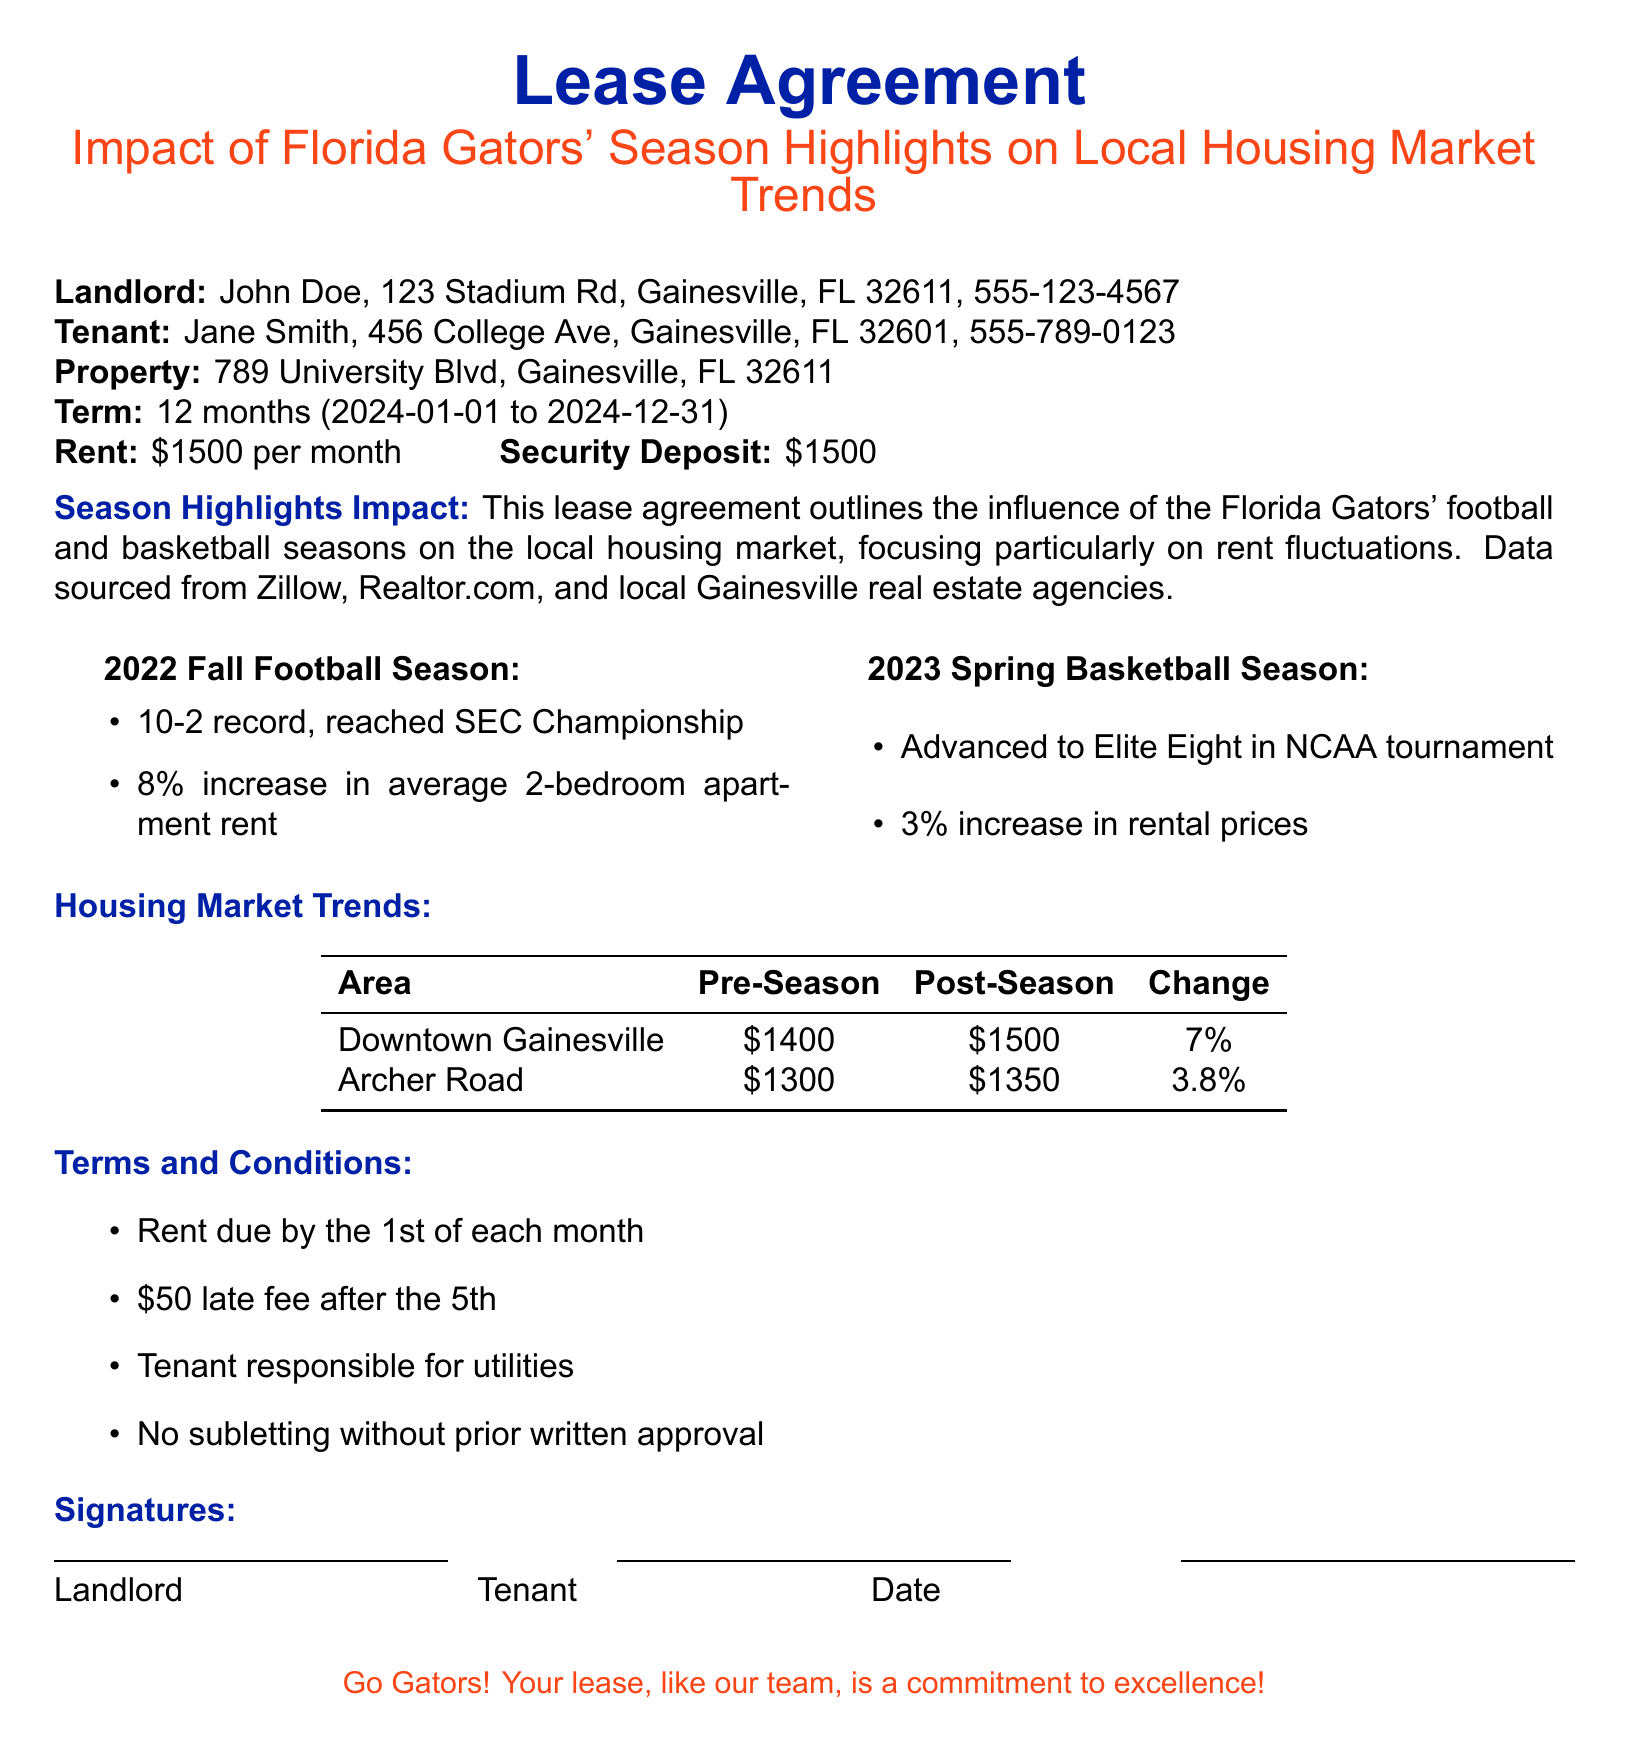What is the name of the landlord? The landlord's name listed in the document is John Doe.
Answer: John Doe What is the rent amount per month? The lease specifies a monthly rent of $1500.
Answer: $1500 What was the Gators' football record in the 2022 Fall season? The document states that the Gators had a 10-2 record during the 2022 Fall football season.
Answer: 10-2 What percentage did the average 2-bedroom apartment rent increase during the 2022 Fall season? The document mentions an 8% increase in rent for 2-bedroom apartments during the 2022 Fall season.
Answer: 8% What was the rent increase percentage in Downtown Gainesville? According to the document, the rent increase in Downtown Gainesville was 7%.
Answer: 7% What are tenants responsible for according to the lease? The lease agreement states that the tenant is responsible for utilities.
Answer: Utilities What is the security deposit amount? The lease indicates a security deposit of $1500.
Answer: $1500 What is the late fee charged after the 5th of each month? The document specifies a late fee of $50 after the 5th of the month.
Answer: $50 What is the start date of the lease term? The lease term begins on January 1, 2024.
Answer: January 1, 2024 